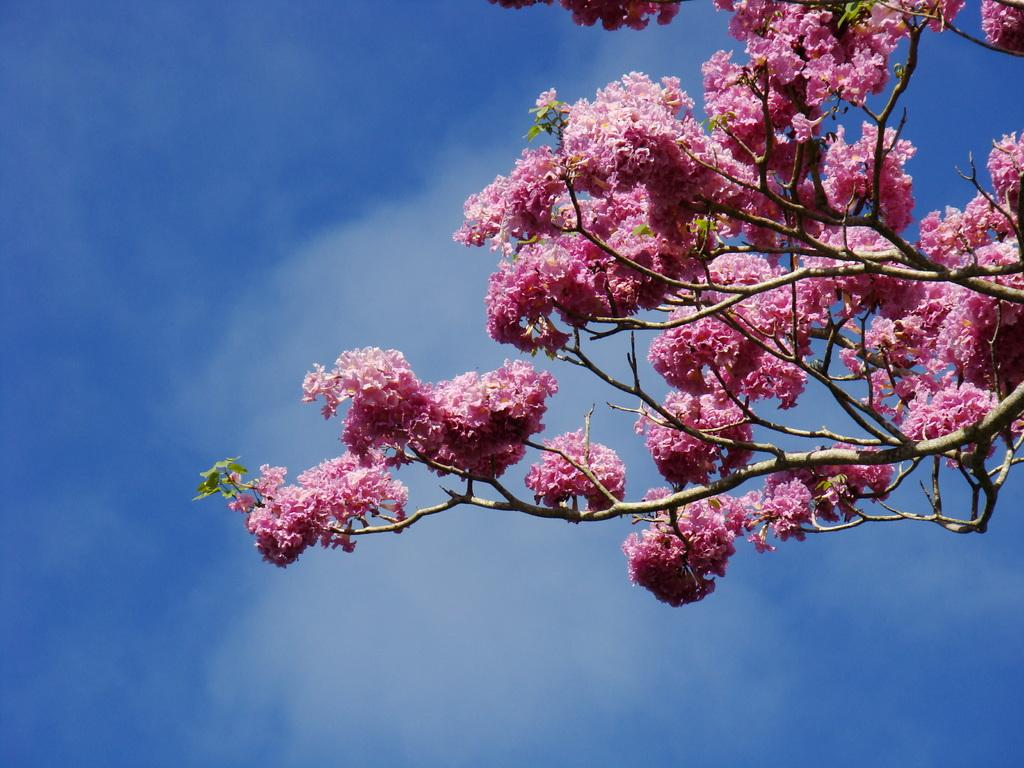What can be seen in the foreground of the picture? There are flowers, leaves, and branches of a tree in the foreground of the picture. What is visible in the background of the image? The background of the image is the sky. Can you describe the vegetation in the foreground of the picture? The vegetation in the foreground includes flowers, leaves, and branches of a tree. How many legs can be seen on the skate in the picture? There is no skate present in the picture, so it is not possible to determine the number of legs on a skate. 